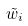<formula> <loc_0><loc_0><loc_500><loc_500>\tilde { w } _ { i }</formula> 